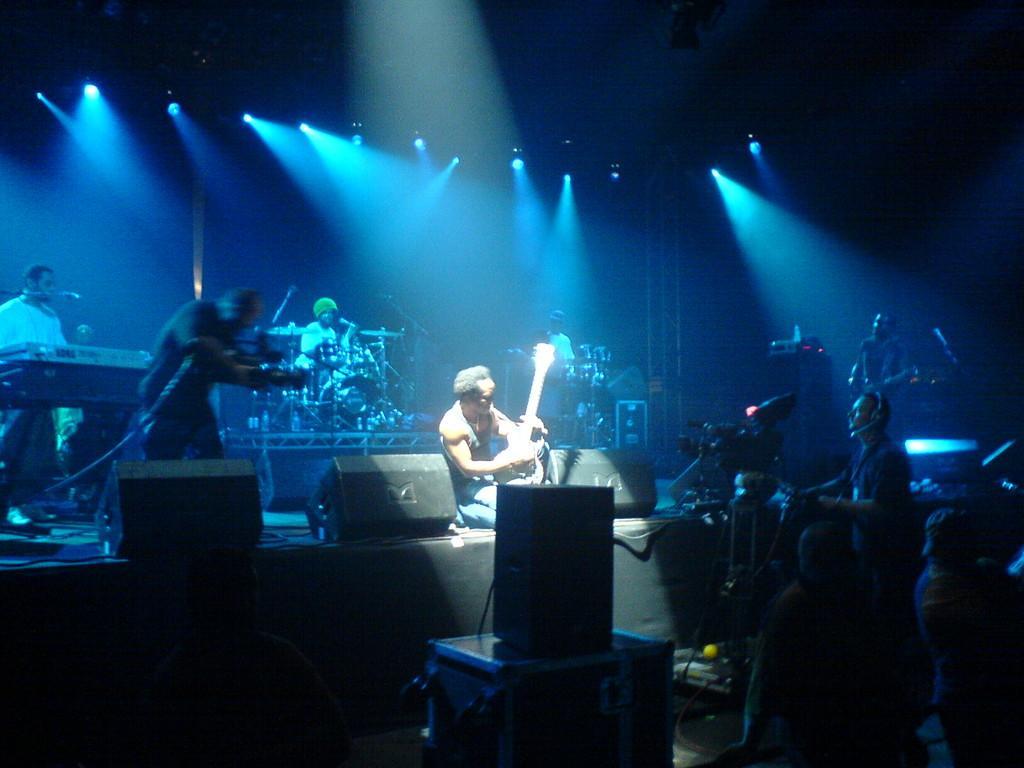In one or two sentences, can you explain what this image depicts? A rock band is performing in a concert in which a person with a guitar is sitting in the front and a cameraman is covering the event. 